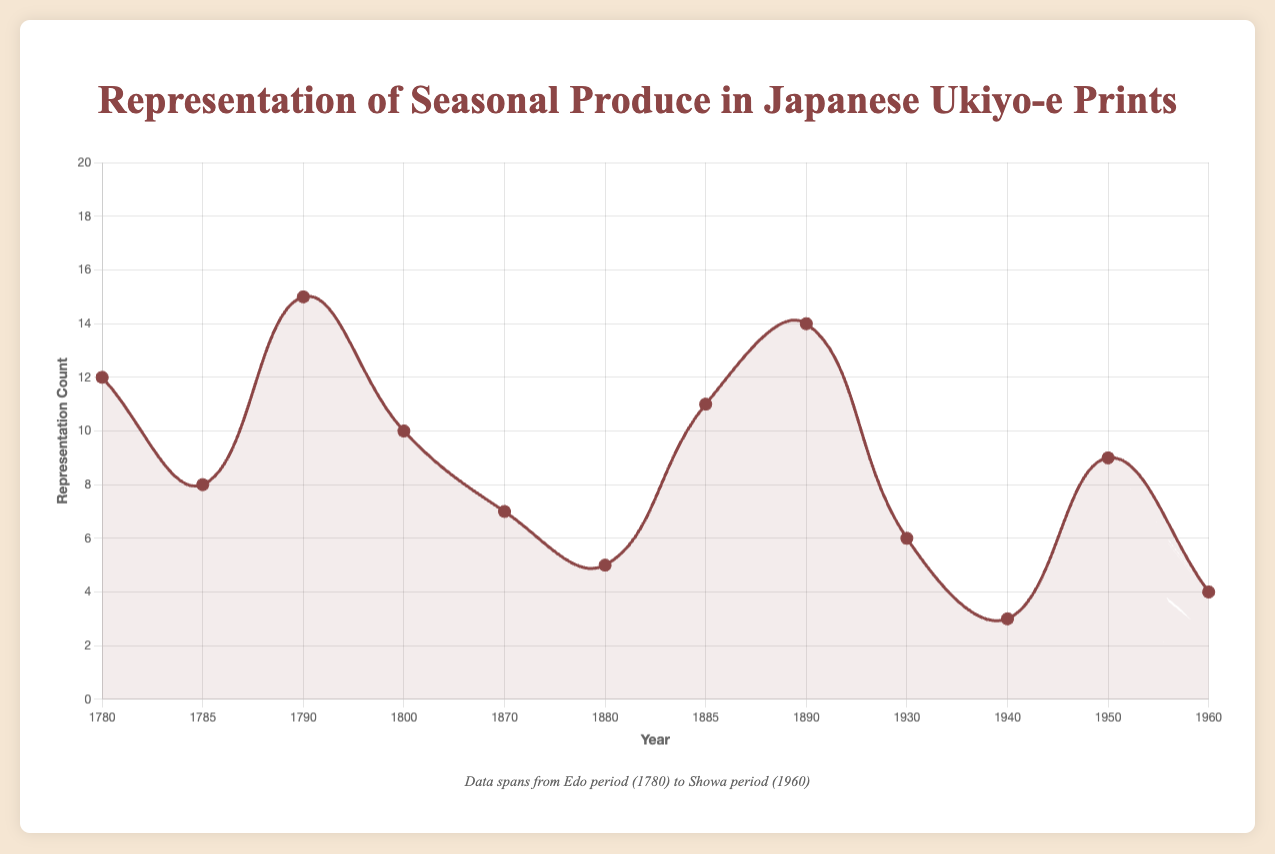What period had the highest representation count for any given year? By examining the peaks of the plot, the highest point occurs in the Edo period, around the year 1790 with a representation count of 15.
Answer: Edo Which season had the lowest representation count during the Showa period? Look at the data points for the Showa period (years 1930, 1940, 1950, 1960) and identify the lowest value. The lowest count occurs in the Summer season of 1940 with a representation count of 3.
Answer: Summer What is the average representation count for the Edo period? Sum up the representation counts for the Edo period (12, 8, 15, 10) and divide by the number of records (4). Calculation: (12 + 8 + 15 + 10)/4 = 11.25
Answer: 11.25 Compare the representation counts between the Spring season of the Edo period and the Meiji period. Which one is higher? Refer to the data points for the Spring season: Edo (1780) has 12 and Meiji (1870) has 7. Comparison shows 12 is higher than 7.
Answer: Edo period (1780) How many artists are represented in the Meiji period data points? By listing the unique artists for the Meiji period (Yoshitoshi, Chikanobu), we see there are 2 unique artists.
Answer: 2 In which year does the Winter season have the highest representation count? Compare all Winter season data points: Edo period (1800) - 10, Meiji period (1890) - 14, Showa period (1960) - 4. The highest count is in 1890 (Meiji period).
Answer: 1890 What was the most frequently represented produce across all periods? Checking the list of produce, "Cherry Blossoms" and "Persimmons" appear more frequently.
Answer: Cherry Blossoms, Persimmons What is the difference between the highest and lowest representation counts in the entire dataset? Identify the highest (15 in 1790) and lowest (3 in 1940), then subtract the lowest from the highest: 15 - 3 = 12.
Answer: 12 Which period had the most varied representation counts based on the visual heights on the plot? Edo period ranges from 8 to 15, Meiji period ranges from 5 to 14, Showa period ranges from 3 to 9. Edo period has the greatest range.
Answer: Edo period Which years fall under the peak seasons for Autumn produce in the given data? For Autumn, identify peaks in the plot: Edo (1790) - 15, Meiji (1885) - 11, Showa (1950) - 9. Therefore, the corresponding years are 1790, 1885, and 1950.
Answer: 1790, 1885, 1950 